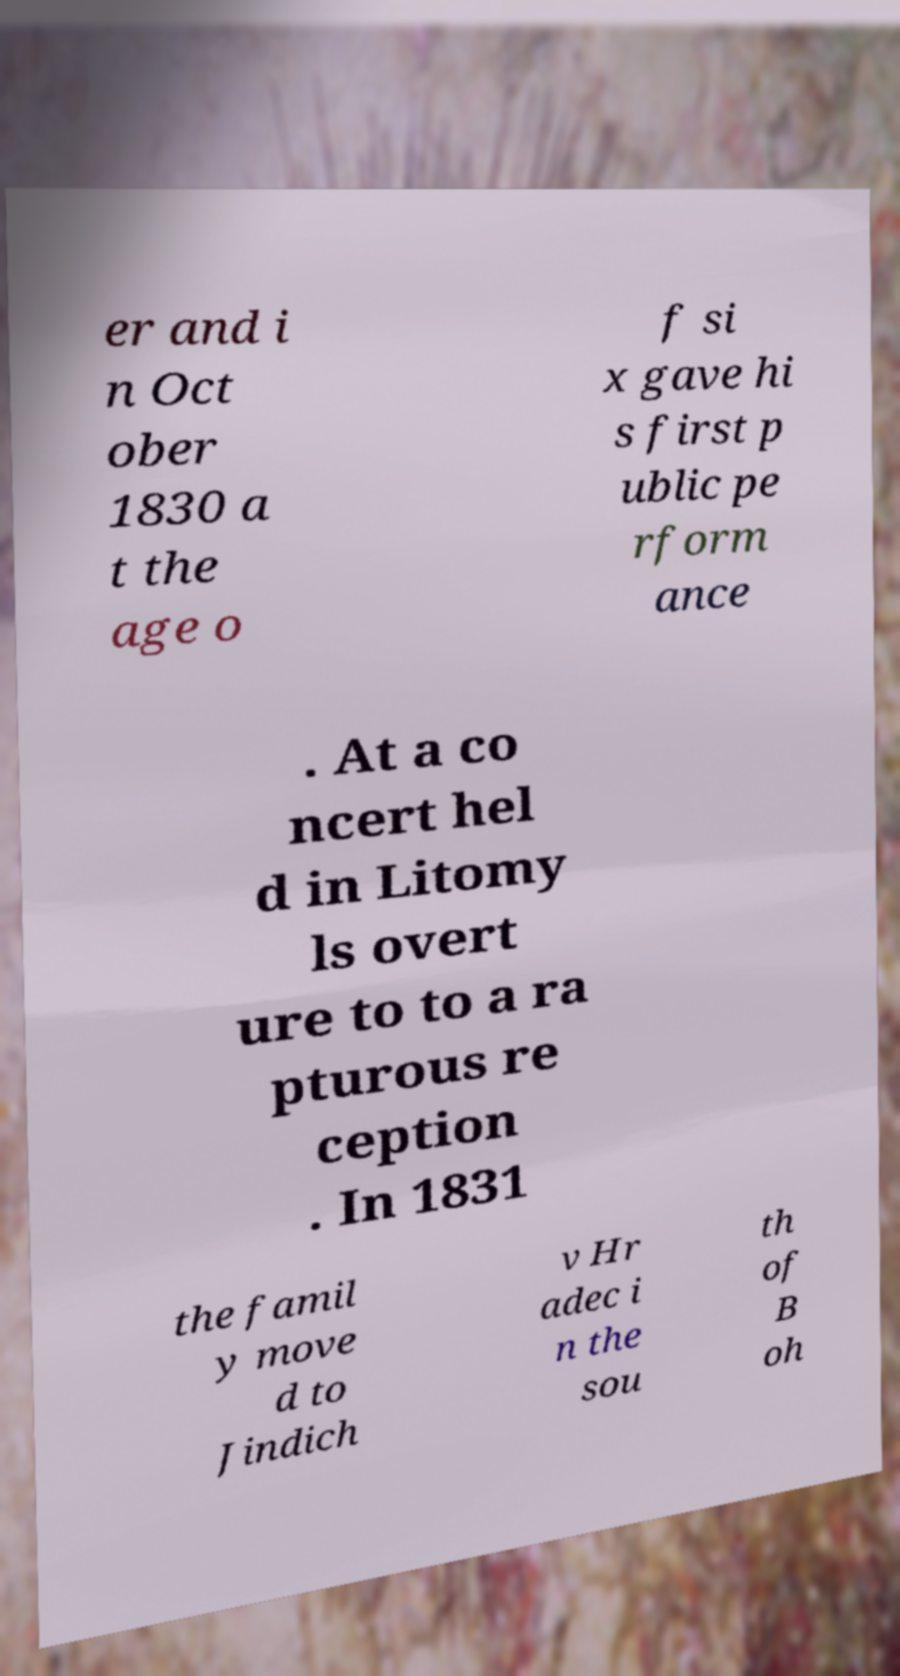For documentation purposes, I need the text within this image transcribed. Could you provide that? er and i n Oct ober 1830 a t the age o f si x gave hi s first p ublic pe rform ance . At a co ncert hel d in Litomy ls overt ure to to a ra pturous re ception . In 1831 the famil y move d to Jindich v Hr adec i n the sou th of B oh 